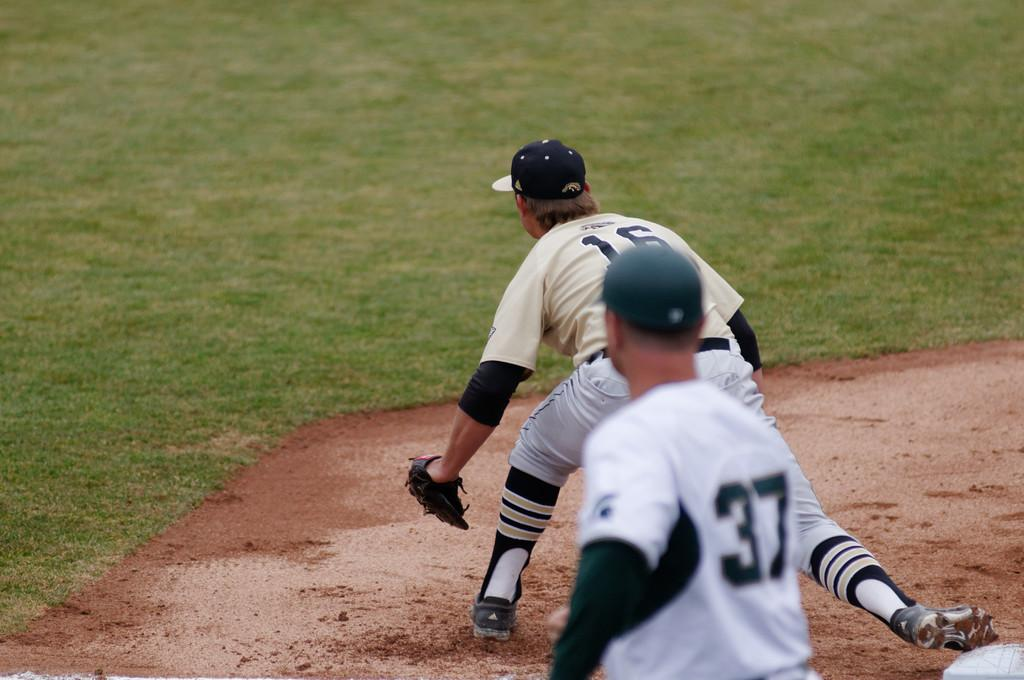<image>
Provide a brief description of the given image. A baseball player wearing number 37 is behind another player wearing 16. 